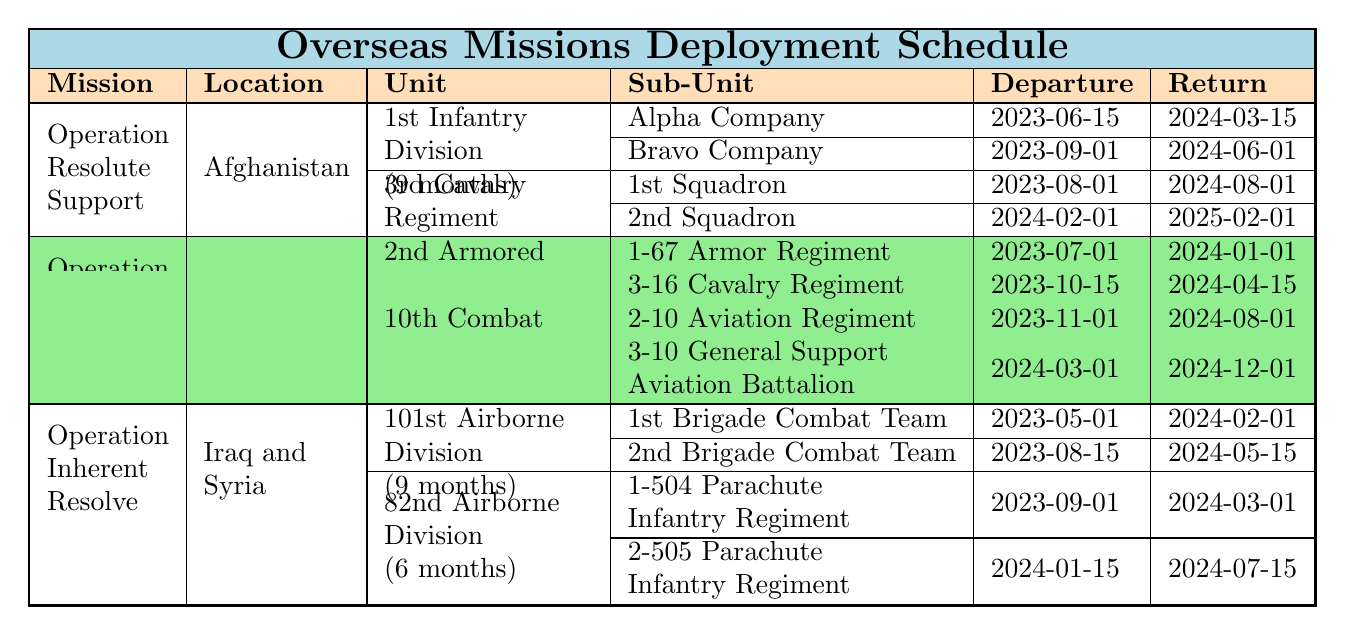What is the location of Operation Resolute Support? The table specifies that Operation Resolute Support is located in Afghanistan.
Answer: Afghanistan Which unit has a deployment duration of 6 months in Operation Atlantic Resolve? The table shows that the 2nd Armored Brigade Combat Team has a deployment duration of 6 months.
Answer: 2nd Armored Brigade Combat Team What is the departure date of Bravo Company for Operation Resolute Support? The table indicates that Bravo Company departs on 2023-09-01 for Operation Resolute Support.
Answer: 2023-09-01 How many battalions are deployed under the 10th Combat Aviation Brigade? The table lists two battalions under the 10th Combat Aviation Brigade, which are 2-10 Aviation Regiment and 3-10 General Support Aviation Battalion.
Answer: 2 Is the 82nd Airborne Division's deployment longer than 6 months? The table shows that the 82nd Airborne Division has a deployment duration of 6 months, which means it is not longer than 6 months.
Answer: No What is the difference in deployment duration between the 3rd Cavalry Regiment and the 101st Airborne Division? The 3rd Cavalry Regiment has a deployment duration of 12 months, while the 101st Airborne Division has a deployment duration of 9 months. The difference is 12 - 9 = 3 months.
Answer: 3 months For how long was Alpha Company deployed in Operation Resolute Support? The deployment duration for Alpha Company is given as part of the 1st Infantry Division's deployment, which is 9 months.
Answer: 9 months What is the latest return date for any unit mentioned in the table? The table indicates that the latest return date is for 2nd Squadron of the 3rd Cavalry Regiment, which is 2025-02-01.
Answer: 2025-02-01 Which operation has units that are deployed in both Iraq and Syria? The table shows that Operation Inherent Resolve includes units that are deployed in both Iraq and Syria.
Answer: Operation Inherent Resolve How many total companies are deployed under the 1st Infantry Division? The table states that Alpha Company and Bravo Company are both deployed under the 1st Infantry Division, totaling 2 companies.
Answer: 2 What is the rotation schedule for the 3-16 Cavalry Regiment? The table specifies that the 3-16 Cavalry Regiment departs on 2023-10-15 and returns on 2024-04-15.
Answer: Departing 2023-10-15, returning 2024-04-15 